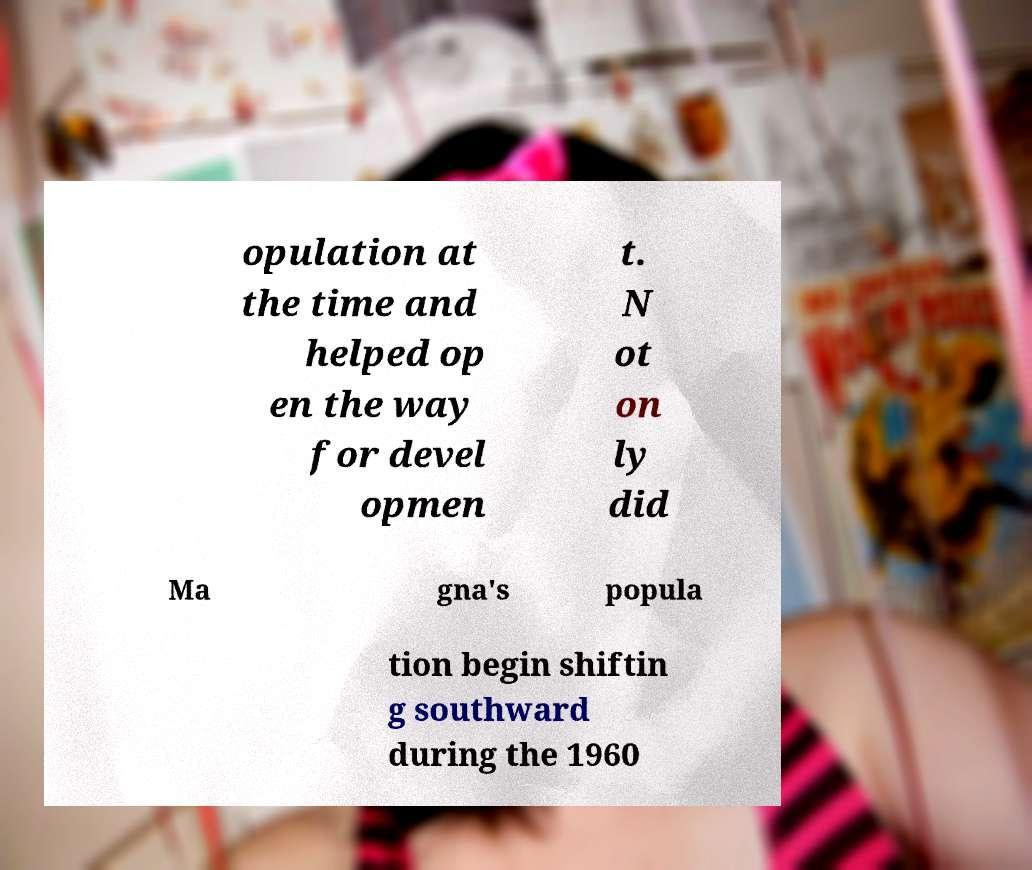Can you accurately transcribe the text from the provided image for me? opulation at the time and helped op en the way for devel opmen t. N ot on ly did Ma gna's popula tion begin shiftin g southward during the 1960 